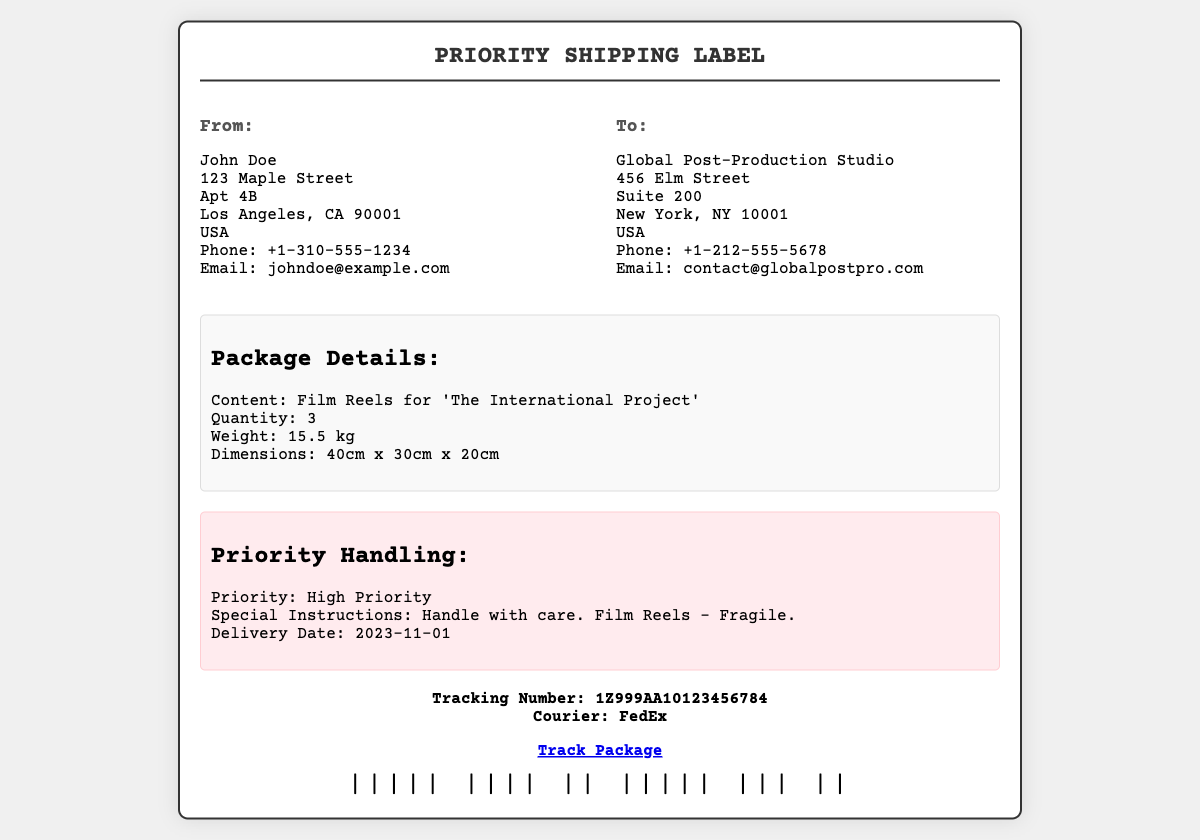What is the sender's name? The sender's name is provided at the top of the shipping label in the "From" section.
Answer: John Doe What is the delivery date? The delivery date is mentioned in the "Priority Handling" section of the label.
Answer: 2023-11-01 What is the weight of the package? The weight is listed in the "Package Details" section.
Answer: 15.5 kg What is the recipient's email? The recipient's email is featured in the "To" section under the address.
Answer: contact@globalpostpro.com How many film reels are being sent? The quantity is specified in the "Package Details" section.
Answer: 3 What is the tracking number? The tracking number is provided in the tracking section near the bottom of the label.
Answer: 1Z999AA10123456784 What is the priority level of the shipment? The priority level is indicated in the "Priority Handling" section.
Answer: High Priority What special instructions are given for handling? Special instructions are noted in the "Priority Handling" section.
Answer: Handle with care. Film Reels - Fragile What courier service is being used? The courier service name is mentioned in the tracking section of the document.
Answer: FedEx 